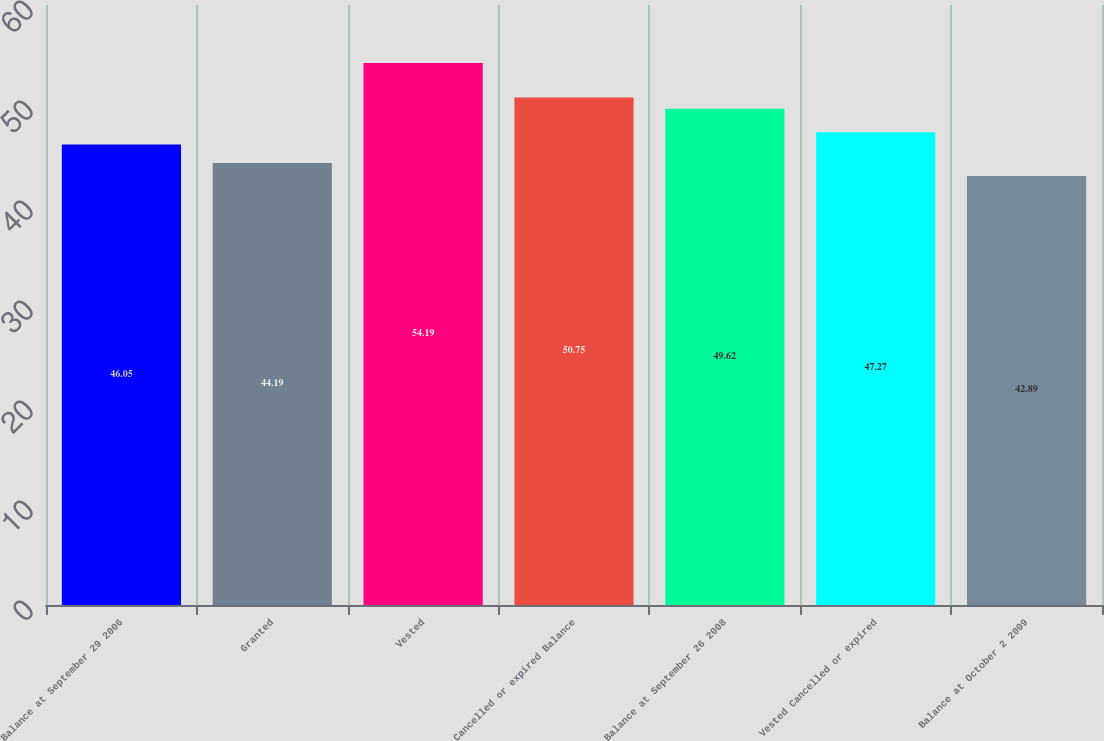Convert chart to OTSL. <chart><loc_0><loc_0><loc_500><loc_500><bar_chart><fcel>Balance at September 29 2006<fcel>Granted<fcel>Vested<fcel>Cancelled or expired Balance<fcel>Balance at September 26 2008<fcel>Vested Cancelled or expired<fcel>Balance at October 2 2009<nl><fcel>46.05<fcel>44.19<fcel>54.19<fcel>50.75<fcel>49.62<fcel>47.27<fcel>42.89<nl></chart> 